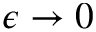<formula> <loc_0><loc_0><loc_500><loc_500>\epsilon \to 0</formula> 